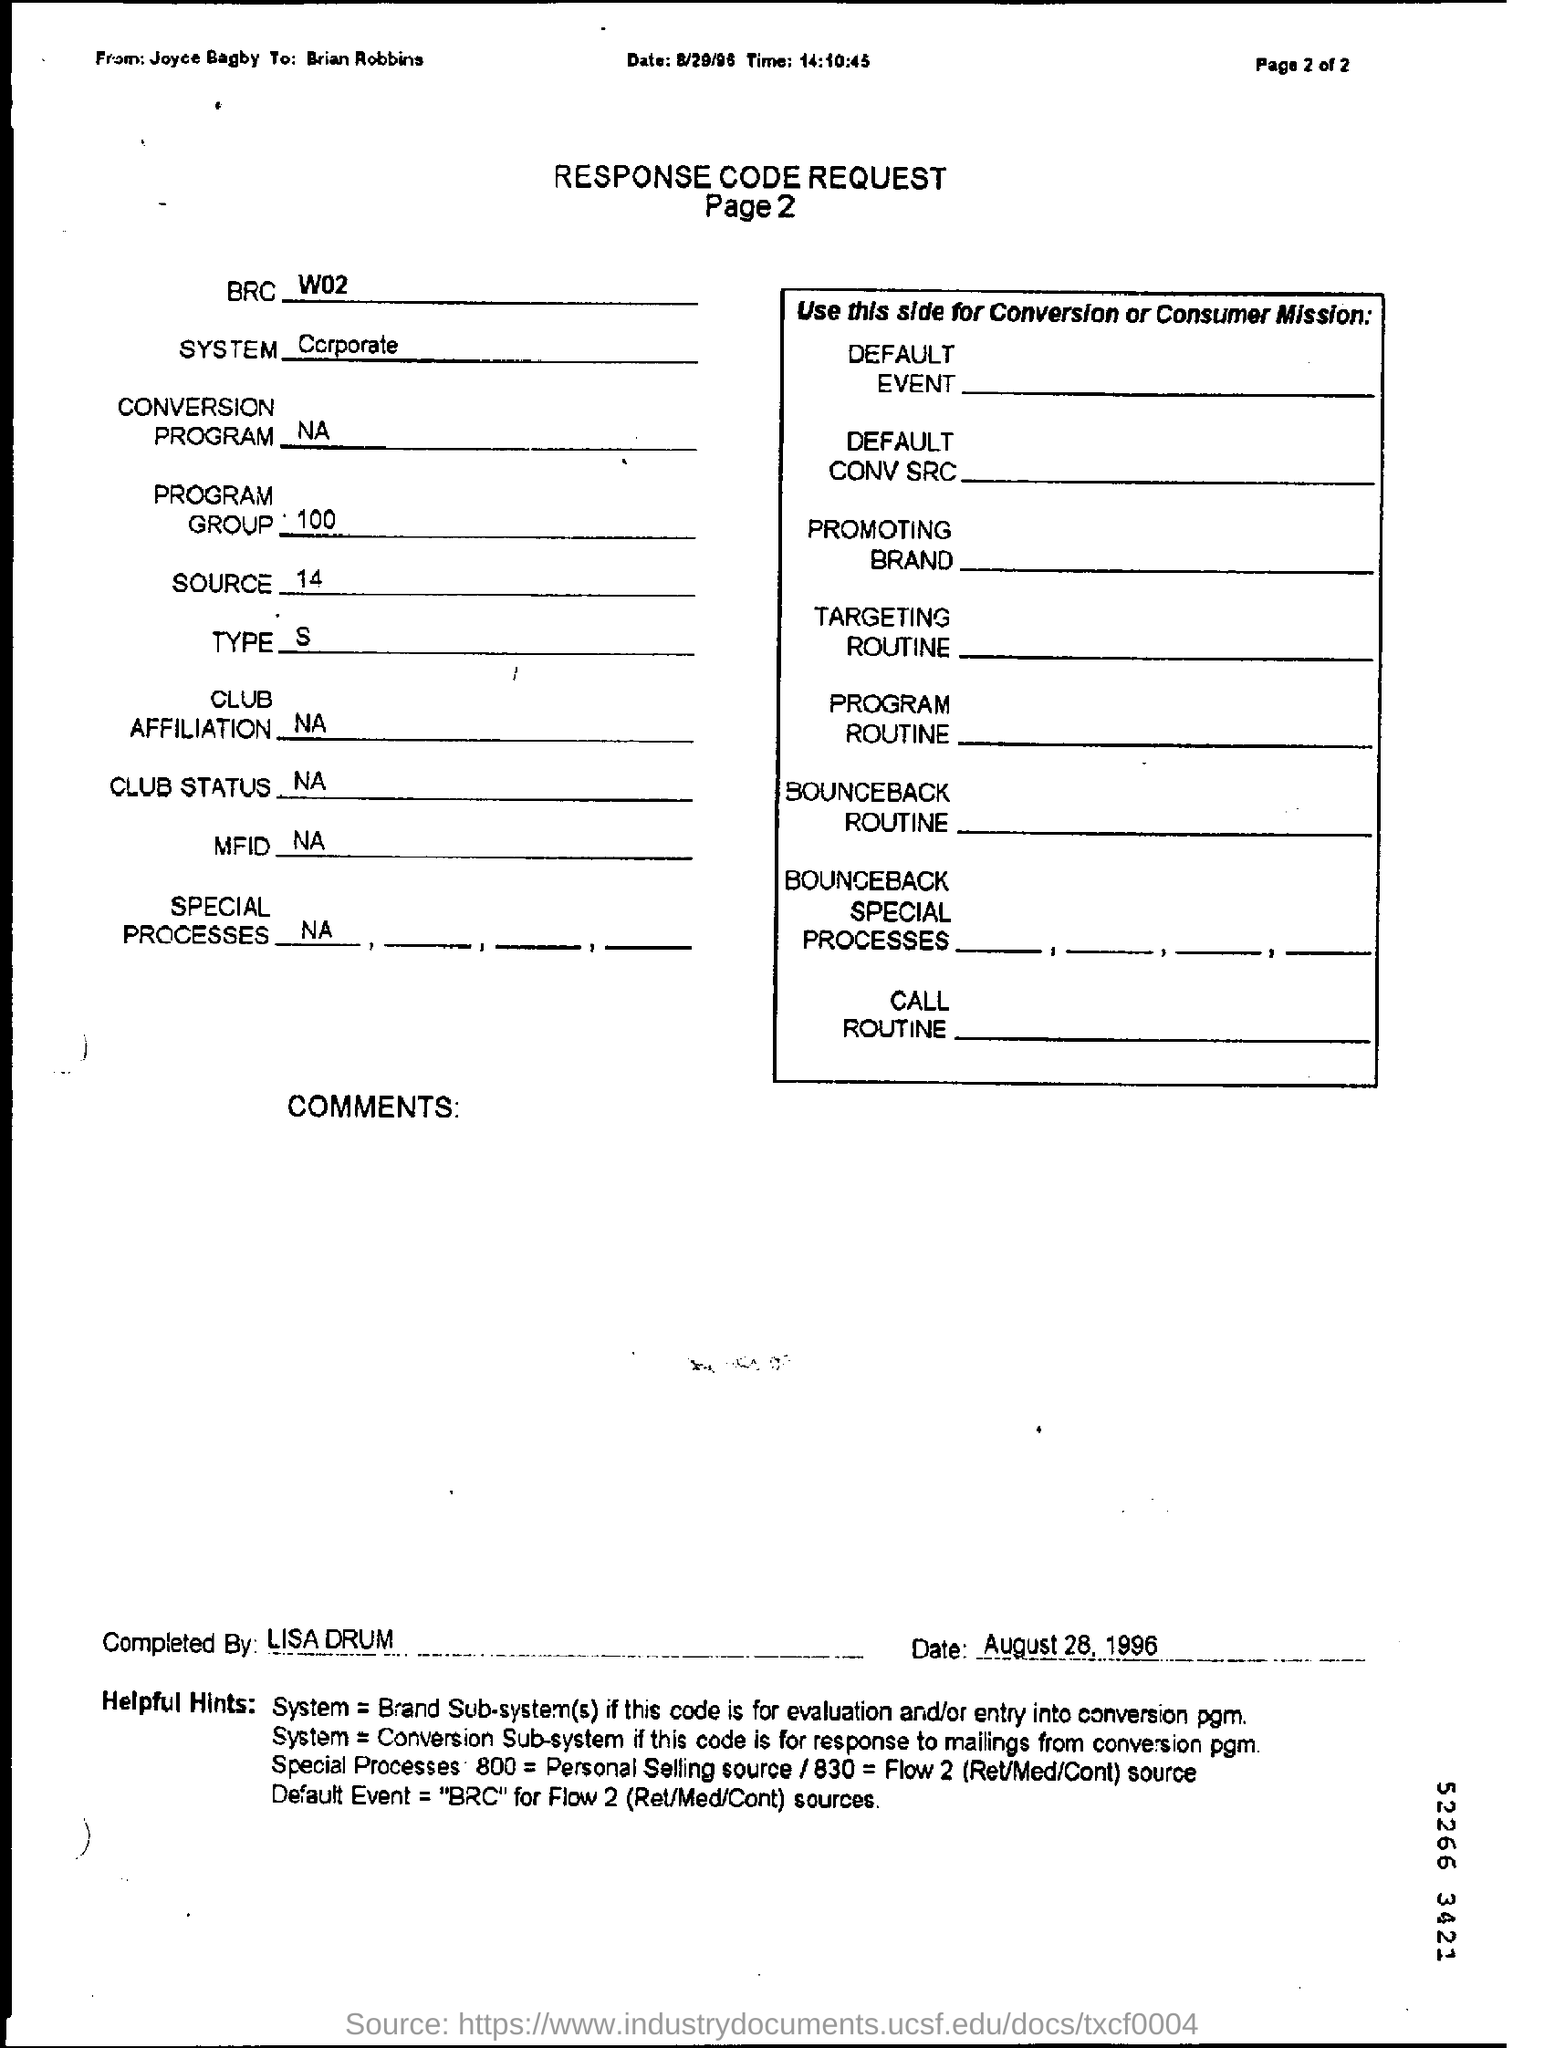Draw attention to some important aspects in this diagram. The completion of this response code request is attributed to Lisa Drum. Please include the page number of the response in your reply. The second page of the request is referred to. The response code request is from Joyce Bagby. The response code request is written to Brian Robbins. 